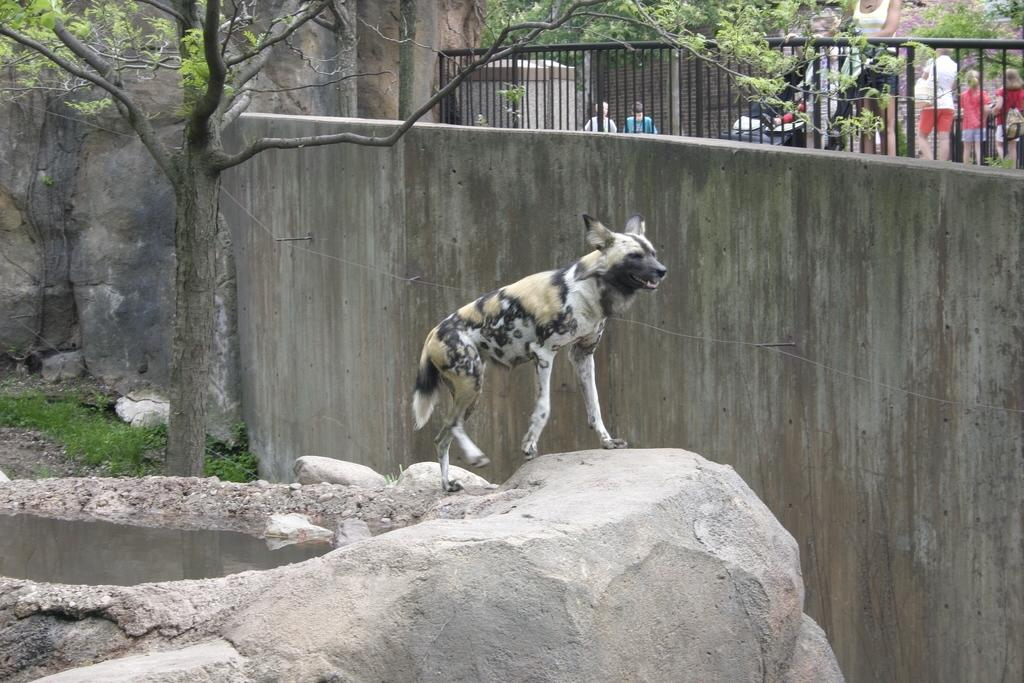What type of living creature is present in the image? There is an animal in the image. Are there any human figures in the image? Yes, there are people in the image. What natural elements can be seen in the image? There are rocks, water, trees, and grass in the image. What man-made structure is visible in the image? There is a wall in the image. What type of stem can be seen growing from the rocks in the image? There is no stem growing from the rocks in the image. What direction does the sun appear to be setting in the image? The image does not show the sun, so it is not possible to determine the direction of the sunset. 